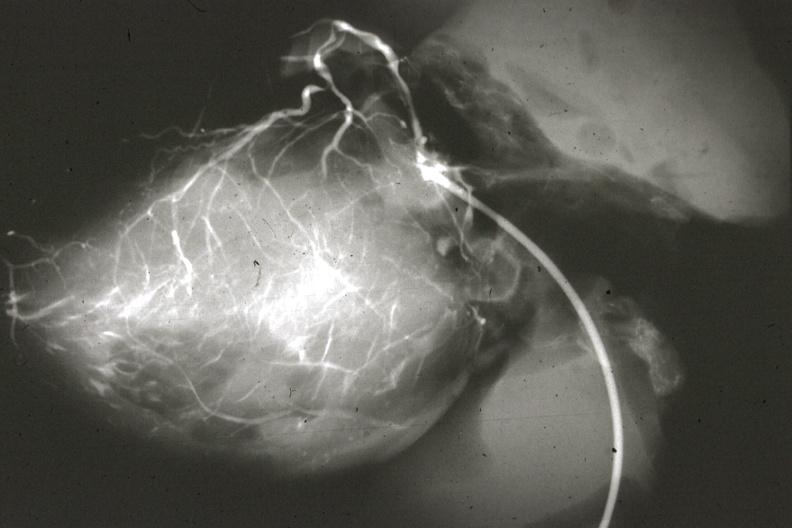s anomalous origin left from pulmonary artery?
Answer the question using a single word or phrase. Yes 